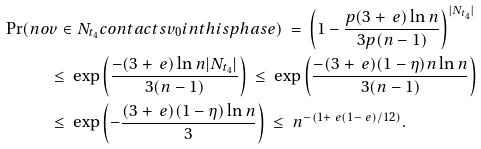Convert formula to latex. <formula><loc_0><loc_0><loc_500><loc_500>\Pr ( n o & v \in N _ { t _ { 4 } } c o n t a c t s v _ { 0 } i n t h i s p h a s e ) \ = \ \left ( 1 - \frac { p ( 3 + \ e ) \ln n } { 3 p ( n - 1 ) } \right ) ^ { | N _ { t _ { 4 } } | } \\ & \leq \ \exp \left ( \frac { - ( 3 + \ e ) \ln n | N _ { t _ { 4 } } | } { 3 ( n - 1 ) } \right ) \ \leq \ \exp \left ( \frac { - ( 3 + \ e ) ( 1 - \eta ) n \ln n } { 3 ( n - 1 ) } \right ) \\ & \leq \ \exp \left ( - \frac { ( 3 + \ e ) ( 1 - \eta ) \ln n } { 3 } \right ) \ \leq \ n ^ { - \left ( 1 + \ e ( 1 - \ e ) / 1 2 \right ) } .</formula> 